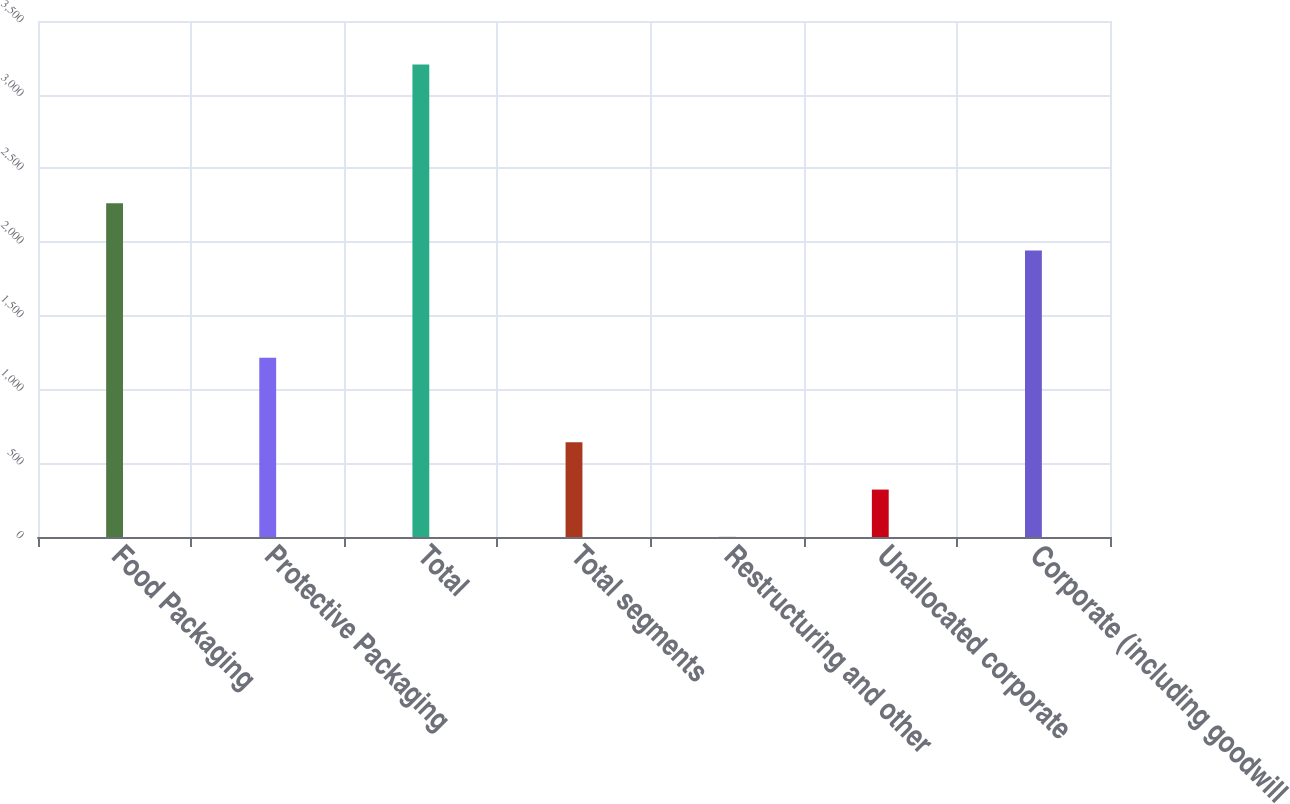<chart> <loc_0><loc_0><loc_500><loc_500><bar_chart><fcel>Food Packaging<fcel>Protective Packaging<fcel>Total<fcel>Total segments<fcel>Restructuring and other<fcel>Unallocated corporate<fcel>Corporate (including goodwill<nl><fcel>2263.8<fcel>1216.3<fcel>3204.3<fcel>641.9<fcel>1.3<fcel>321.6<fcel>1943.5<nl></chart> 